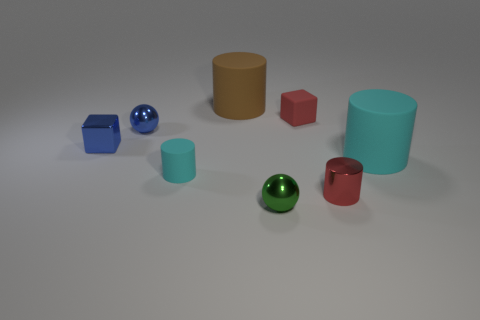What material is the large object that is on the left side of the big object that is to the right of the green object?
Offer a terse response. Rubber. There is a tiny cylinder on the right side of the red matte object; is its color the same as the tiny matte cube?
Keep it short and to the point. Yes. How many tiny metallic cylinders are the same color as the tiny rubber cylinder?
Offer a terse response. 0. The other shiny thing that is the same shape as the big cyan object is what color?
Offer a very short reply. Red. Does the green metal sphere have the same size as the blue metal ball?
Give a very brief answer. Yes. Is the number of brown cylinders that are behind the tiny green object the same as the number of green spheres in front of the small red cylinder?
Make the answer very short. Yes. Are any tiny cyan rubber objects visible?
Provide a short and direct response. Yes. The brown thing that is the same shape as the large cyan matte object is what size?
Your response must be concise. Large. How big is the metallic thing that is in front of the tiny red metal thing?
Ensure brevity in your answer.  Small. Is the number of small cylinders behind the small red metal cylinder greater than the number of gray metallic balls?
Provide a short and direct response. Yes. 